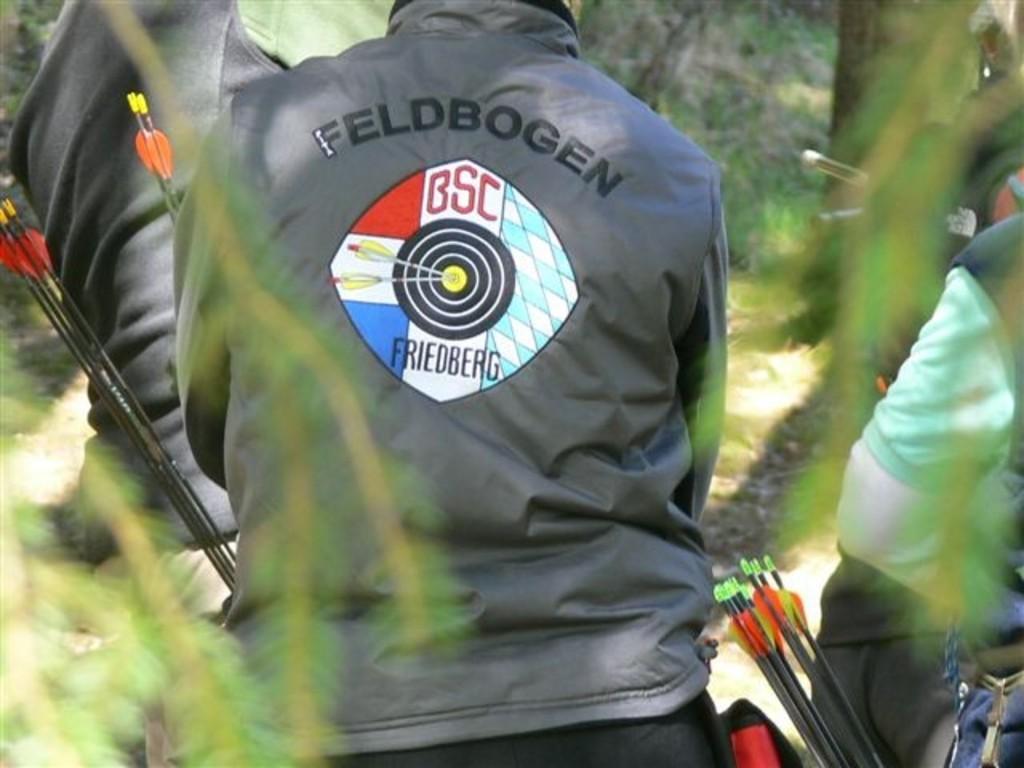How would you summarize this image in a sentence or two? In the picture we can see three people standing and turning back side and they are in jacket and holding arrows and in front of them we can see some trees and plants. 